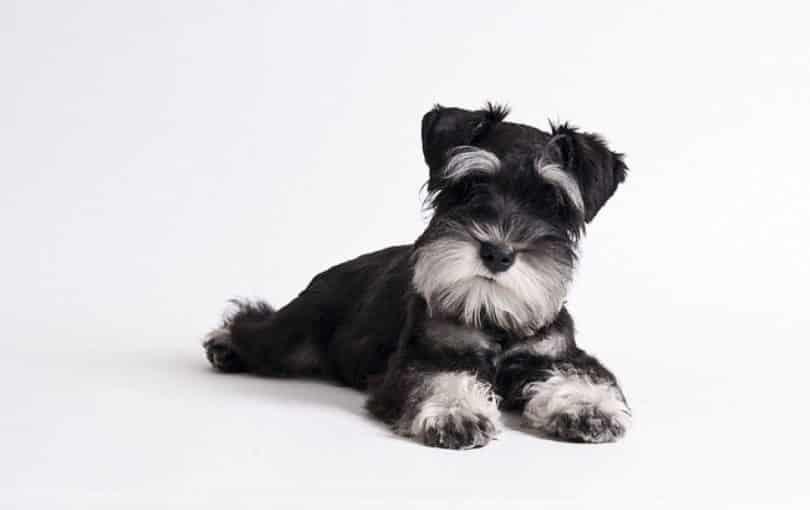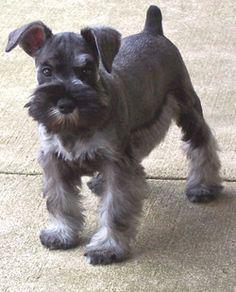The first image is the image on the left, the second image is the image on the right. For the images shown, is this caption "The dog in the image on the right is standing on all fours." true? Answer yes or no. Yes. The first image is the image on the left, the second image is the image on the right. Evaluate the accuracy of this statement regarding the images: "One camera-gazing schnauzer is standing on all fours on a surface that looks like cement.". Is it true? Answer yes or no. Yes. 